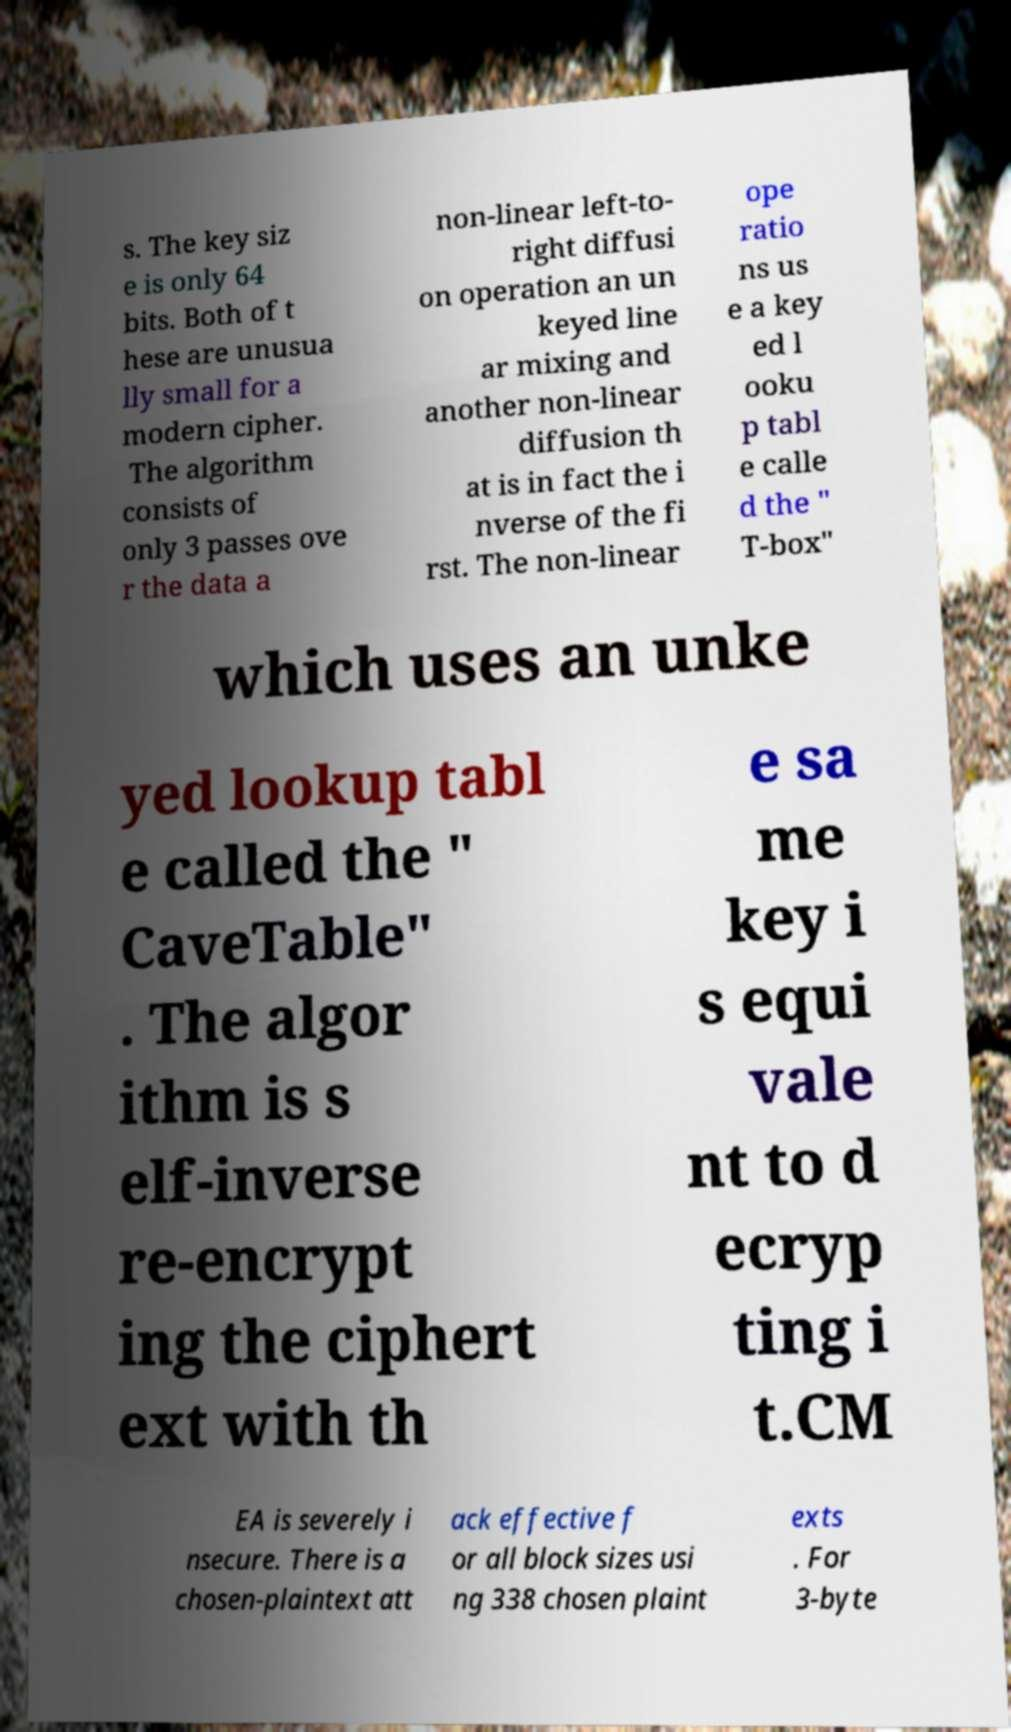What messages or text are displayed in this image? I need them in a readable, typed format. s. The key siz e is only 64 bits. Both of t hese are unusua lly small for a modern cipher. The algorithm consists of only 3 passes ove r the data a non-linear left-to- right diffusi on operation an un keyed line ar mixing and another non-linear diffusion th at is in fact the i nverse of the fi rst. The non-linear ope ratio ns us e a key ed l ooku p tabl e calle d the " T-box" which uses an unke yed lookup tabl e called the " CaveTable" . The algor ithm is s elf-inverse re-encrypt ing the ciphert ext with th e sa me key i s equi vale nt to d ecryp ting i t.CM EA is severely i nsecure. There is a chosen-plaintext att ack effective f or all block sizes usi ng 338 chosen plaint exts . For 3-byte 